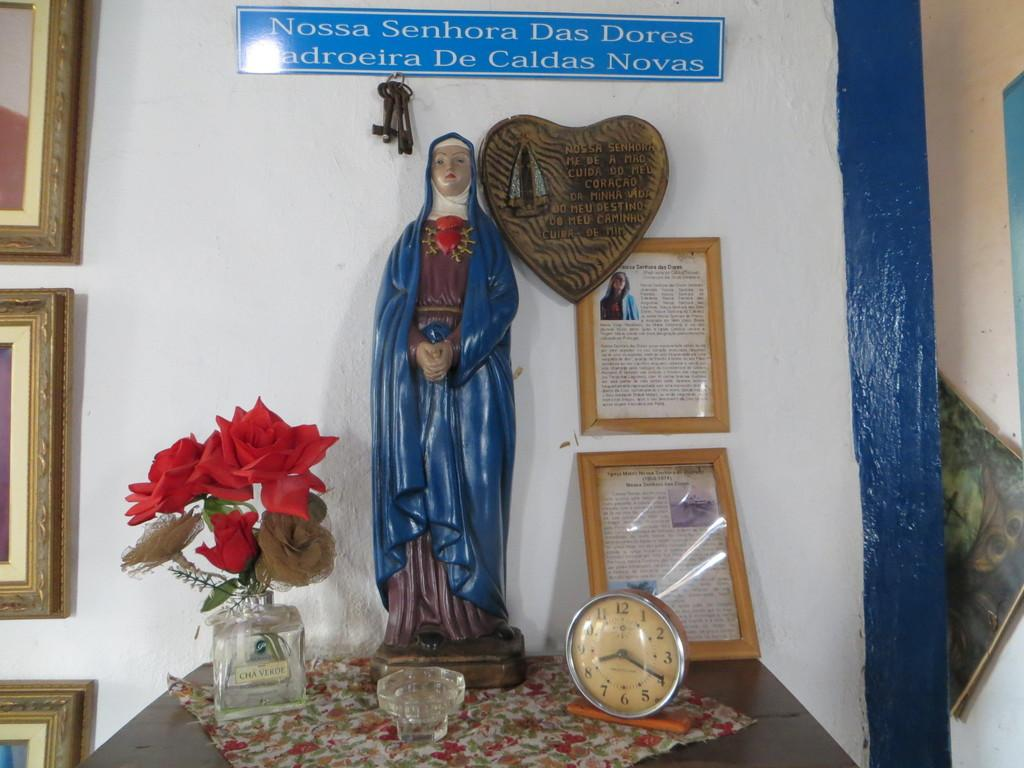<image>
Describe the image concisely. A religious statue with a clock that reads 8:20. 